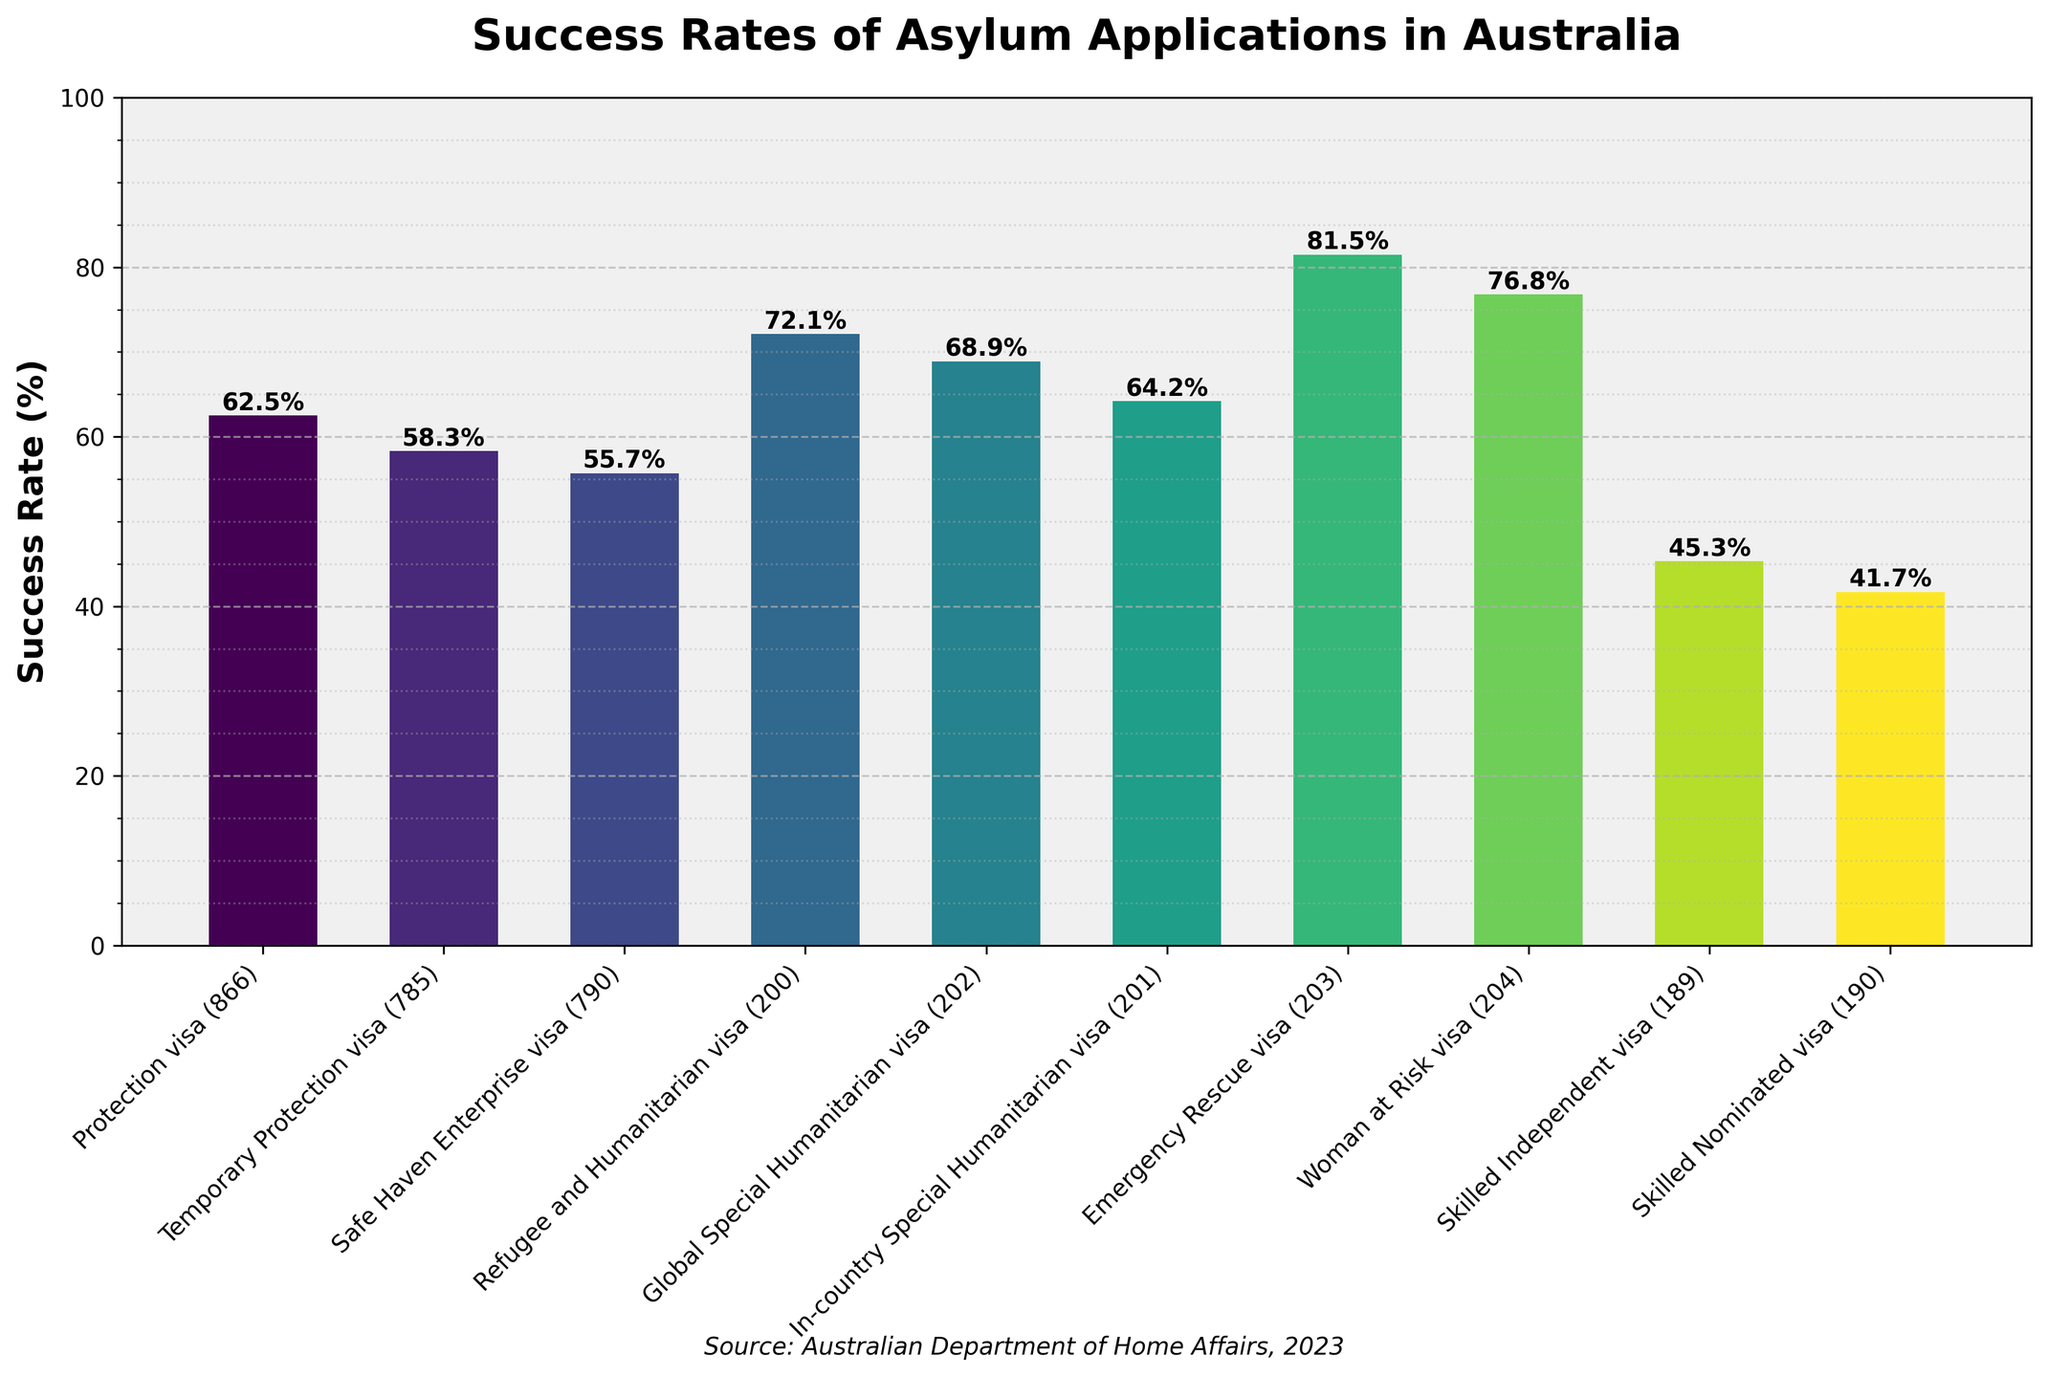What is the success rate of the Emergency Rescue visa (203)? Looking at the figure, find the bar labeled "Emergency Rescue visa (203)" and read the success rate value marked on the top of the bar.
Answer: 81.5% Which visa category has the lowest success rate? Identify the bar with the smallest height in the figure and check the corresponding visa category label.
Answer: Skilled Nominated visa (190) Which visa category has a success rate higher than 70% but less than 80%? Identify the bars with a height corresponding to a success rate between 70% and 80% and check the visa category labels.
Answer: Refugee and Humanitarian visa (200) and Woman at Risk visa (204) What is the difference in success rate between the Protection visa (866) and the Skilled Independent visa (189)? Find the success rates of both visa categories from the figure, then subtract the smaller value from the larger one: 62.5 - 45.3.
Answer: 17.2% Calculate the average success rate of all the visa categories. Add up all the success rates from the figure and divide by the total number of visa categories: (62.5 + 58.3 + 55.7 + 72.1 + 68.9 + 64.2 + 81.5 + 76.8 + 45.3 + 41.7) / 10.
Answer: 62.7% Which visa categories have equal or higher success rates than the In-country Special Humanitarian visa (201)? Find the success rate of the In-country Special Humanitarian visa (201) from the figure and identify all bars with an equal or higher value.
Answer: Protection visa (866), Refugee and Humanitarian visa (200), Global Special Humanitarian visa (202), Emergency Rescue visa (203), Woman at Risk visa (204) How many visa categories have a success rate below 60%? Count the number of bars with a height indicating a success rate below 60%.
Answer: 4 Compare the success rates of the Temporary Protection visa (785) and the Safe Haven Enterprise visa (790). Look at the success rates for both visa categories in the figure and identify which one is higher.
Answer: Temporary Protection visa (785) has a higher success rate Which visa category is represented with the tallest bar? Identify the bar with the greatest height and check the corresponding visa category label.
Answer: Emergency Rescue visa (203) How many visa categories have success rates between 50% and 70%? Count the number of bars with heights corresponding to success rates between 50% and 70%.
Answer: 5 